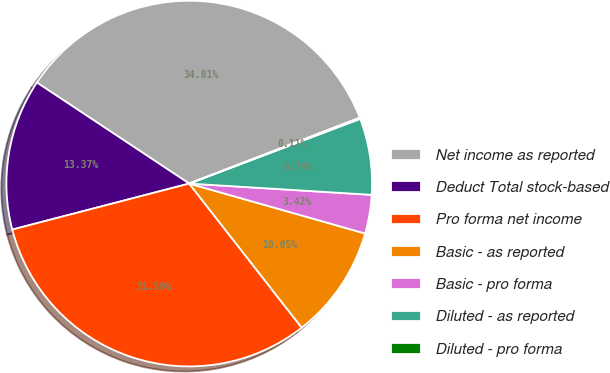Convert chart to OTSL. <chart><loc_0><loc_0><loc_500><loc_500><pie_chart><fcel>Net income as reported<fcel>Deduct Total stock-based<fcel>Pro forma net income<fcel>Basic - as reported<fcel>Basic - pro forma<fcel>Diluted - as reported<fcel>Diluted - pro forma<nl><fcel>34.81%<fcel>13.37%<fcel>31.5%<fcel>10.05%<fcel>3.42%<fcel>6.74%<fcel>0.11%<nl></chart> 